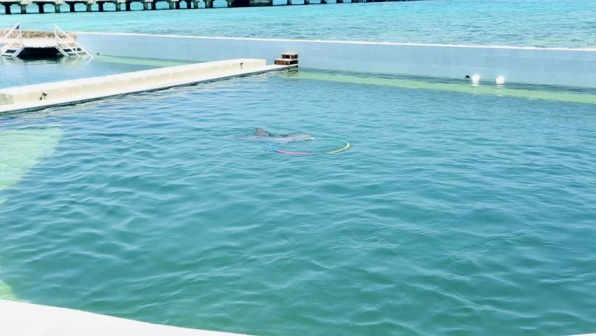How might one feel while standing on the pier in this image? Standing on the pier in this image could evoke a sense of tranquility and connection with nature. The gentle sound of the water lapping against the pier, combined with the sight of the elegant dolphin swimming nearby, would create a calming and soothing atmosphere. The fresh, salty sea air and the openness of the water could instill a sense of freedom and relaxation. Overall, the experience could be both refreshing and meditative. Imagine if this scene was part of a story. How might the dolphin interact with visitors? In a story, the dolphin might play an integral role in engaging with visitors. Visitors could gather at the pier to watch the dolphin perform playful tricks and swim gracefully through the water, demonstrating its intelligence and curiosity. The dolphin could also be part of interactive sessions where select visitors get the opportunity to feed it or even swim alongside it under the guidance of trained staff. Additionally, the dolphin might respond to signals from a trainer, flipping in the air, or pushing a floating ball, showcasing a bond between human and marine life that captivates and educates the audience. 